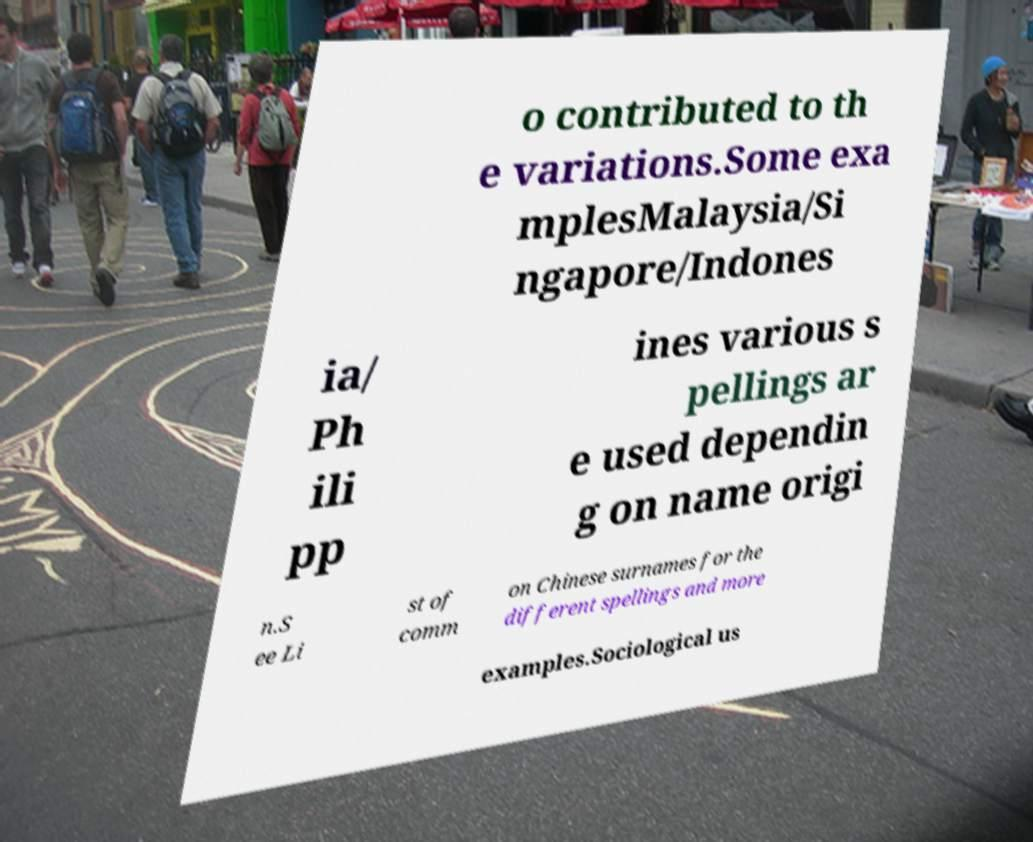Could you assist in decoding the text presented in this image and type it out clearly? o contributed to th e variations.Some exa mplesMalaysia/Si ngapore/Indones ia/ Ph ili pp ines various s pellings ar e used dependin g on name origi n.S ee Li st of comm on Chinese surnames for the different spellings and more examples.Sociological us 